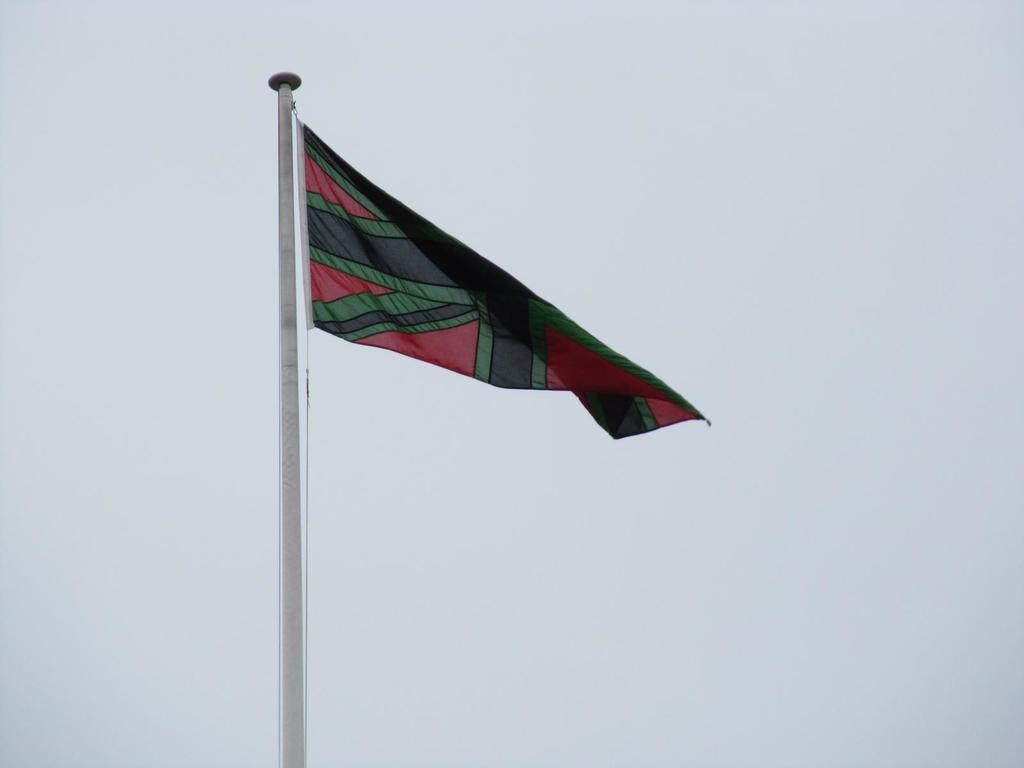What is the main object in the image? There is a flag on a pole in the image. What can be seen in the background of the image? The background of the image is white. How much addition is required to solve the cub problem in the image? There is no cub problem or addition present in the image; it only features a flag on a pole with a white background. 